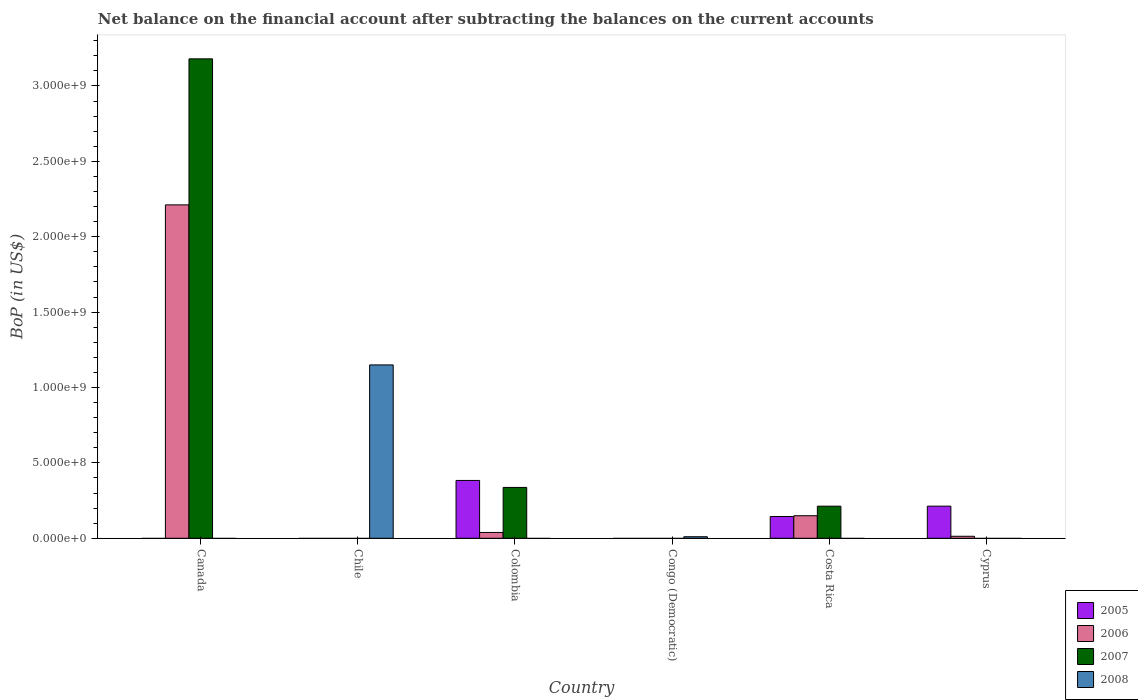Are the number of bars per tick equal to the number of legend labels?
Your answer should be very brief. No. Are the number of bars on each tick of the X-axis equal?
Provide a succinct answer. No. What is the Balance of Payments in 2006 in Cyprus?
Your response must be concise. 1.33e+07. Across all countries, what is the maximum Balance of Payments in 2005?
Keep it short and to the point. 3.84e+08. Across all countries, what is the minimum Balance of Payments in 2007?
Your answer should be compact. 0. What is the total Balance of Payments in 2006 in the graph?
Keep it short and to the point. 2.41e+09. What is the difference between the Balance of Payments in 2005 in Costa Rica and that in Cyprus?
Your response must be concise. -6.87e+07. What is the difference between the Balance of Payments in 2005 in Cyprus and the Balance of Payments in 2006 in Chile?
Your answer should be very brief. 2.13e+08. What is the average Balance of Payments in 2006 per country?
Your response must be concise. 4.02e+08. What is the difference between the Balance of Payments of/in 2007 and Balance of Payments of/in 2006 in Colombia?
Make the answer very short. 2.99e+08. What is the ratio of the Balance of Payments in 2007 in Canada to that in Costa Rica?
Your answer should be very brief. 14.93. Is the difference between the Balance of Payments in 2007 in Canada and Costa Rica greater than the difference between the Balance of Payments in 2006 in Canada and Costa Rica?
Your answer should be very brief. Yes. What is the difference between the highest and the second highest Balance of Payments in 2007?
Your answer should be compact. -1.24e+08. What is the difference between the highest and the lowest Balance of Payments in 2006?
Provide a succinct answer. 2.21e+09. How many bars are there?
Offer a terse response. 12. Are all the bars in the graph horizontal?
Your answer should be very brief. No. How many countries are there in the graph?
Ensure brevity in your answer.  6. Does the graph contain grids?
Offer a very short reply. No. How are the legend labels stacked?
Provide a succinct answer. Vertical. What is the title of the graph?
Give a very brief answer. Net balance on the financial account after subtracting the balances on the current accounts. What is the label or title of the X-axis?
Offer a terse response. Country. What is the label or title of the Y-axis?
Keep it short and to the point. BoP (in US$). What is the BoP (in US$) in 2005 in Canada?
Your answer should be very brief. 0. What is the BoP (in US$) in 2006 in Canada?
Provide a short and direct response. 2.21e+09. What is the BoP (in US$) in 2007 in Canada?
Offer a very short reply. 3.18e+09. What is the BoP (in US$) of 2005 in Chile?
Your answer should be compact. 0. What is the BoP (in US$) in 2006 in Chile?
Keep it short and to the point. 0. What is the BoP (in US$) of 2008 in Chile?
Make the answer very short. 1.15e+09. What is the BoP (in US$) of 2005 in Colombia?
Give a very brief answer. 3.84e+08. What is the BoP (in US$) in 2006 in Colombia?
Your response must be concise. 3.87e+07. What is the BoP (in US$) of 2007 in Colombia?
Your answer should be compact. 3.37e+08. What is the BoP (in US$) of 2008 in Colombia?
Make the answer very short. 0. What is the BoP (in US$) in 2005 in Congo (Democratic)?
Give a very brief answer. 0. What is the BoP (in US$) of 2006 in Congo (Democratic)?
Offer a terse response. 0. What is the BoP (in US$) of 2008 in Congo (Democratic)?
Offer a very short reply. 1.03e+07. What is the BoP (in US$) in 2005 in Costa Rica?
Offer a terse response. 1.44e+08. What is the BoP (in US$) of 2006 in Costa Rica?
Give a very brief answer. 1.50e+08. What is the BoP (in US$) of 2007 in Costa Rica?
Make the answer very short. 2.13e+08. What is the BoP (in US$) in 2005 in Cyprus?
Offer a very short reply. 2.13e+08. What is the BoP (in US$) in 2006 in Cyprus?
Keep it short and to the point. 1.33e+07. What is the BoP (in US$) of 2007 in Cyprus?
Your answer should be compact. 0. Across all countries, what is the maximum BoP (in US$) of 2005?
Your response must be concise. 3.84e+08. Across all countries, what is the maximum BoP (in US$) of 2006?
Ensure brevity in your answer.  2.21e+09. Across all countries, what is the maximum BoP (in US$) of 2007?
Provide a short and direct response. 3.18e+09. Across all countries, what is the maximum BoP (in US$) of 2008?
Provide a succinct answer. 1.15e+09. Across all countries, what is the minimum BoP (in US$) of 2006?
Offer a terse response. 0. Across all countries, what is the minimum BoP (in US$) of 2007?
Your response must be concise. 0. Across all countries, what is the minimum BoP (in US$) of 2008?
Provide a succinct answer. 0. What is the total BoP (in US$) of 2005 in the graph?
Your response must be concise. 7.41e+08. What is the total BoP (in US$) in 2006 in the graph?
Your answer should be very brief. 2.41e+09. What is the total BoP (in US$) of 2007 in the graph?
Your answer should be compact. 3.73e+09. What is the total BoP (in US$) of 2008 in the graph?
Give a very brief answer. 1.16e+09. What is the difference between the BoP (in US$) of 2006 in Canada and that in Colombia?
Your answer should be very brief. 2.17e+09. What is the difference between the BoP (in US$) of 2007 in Canada and that in Colombia?
Keep it short and to the point. 2.84e+09. What is the difference between the BoP (in US$) in 2006 in Canada and that in Costa Rica?
Offer a terse response. 2.06e+09. What is the difference between the BoP (in US$) in 2007 in Canada and that in Costa Rica?
Offer a very short reply. 2.97e+09. What is the difference between the BoP (in US$) of 2006 in Canada and that in Cyprus?
Make the answer very short. 2.20e+09. What is the difference between the BoP (in US$) of 2008 in Chile and that in Congo (Democratic)?
Your answer should be compact. 1.14e+09. What is the difference between the BoP (in US$) of 2005 in Colombia and that in Costa Rica?
Your answer should be very brief. 2.39e+08. What is the difference between the BoP (in US$) of 2006 in Colombia and that in Costa Rica?
Keep it short and to the point. -1.11e+08. What is the difference between the BoP (in US$) in 2007 in Colombia and that in Costa Rica?
Provide a short and direct response. 1.24e+08. What is the difference between the BoP (in US$) of 2005 in Colombia and that in Cyprus?
Provide a short and direct response. 1.70e+08. What is the difference between the BoP (in US$) in 2006 in Colombia and that in Cyprus?
Your answer should be very brief. 2.53e+07. What is the difference between the BoP (in US$) of 2005 in Costa Rica and that in Cyprus?
Give a very brief answer. -6.87e+07. What is the difference between the BoP (in US$) in 2006 in Costa Rica and that in Cyprus?
Your answer should be very brief. 1.36e+08. What is the difference between the BoP (in US$) of 2006 in Canada and the BoP (in US$) of 2008 in Chile?
Provide a succinct answer. 1.06e+09. What is the difference between the BoP (in US$) in 2007 in Canada and the BoP (in US$) in 2008 in Chile?
Make the answer very short. 2.03e+09. What is the difference between the BoP (in US$) in 2006 in Canada and the BoP (in US$) in 2007 in Colombia?
Provide a succinct answer. 1.87e+09. What is the difference between the BoP (in US$) of 2006 in Canada and the BoP (in US$) of 2008 in Congo (Democratic)?
Keep it short and to the point. 2.20e+09. What is the difference between the BoP (in US$) of 2007 in Canada and the BoP (in US$) of 2008 in Congo (Democratic)?
Keep it short and to the point. 3.17e+09. What is the difference between the BoP (in US$) of 2006 in Canada and the BoP (in US$) of 2007 in Costa Rica?
Offer a terse response. 2.00e+09. What is the difference between the BoP (in US$) of 2005 in Colombia and the BoP (in US$) of 2008 in Congo (Democratic)?
Provide a short and direct response. 3.73e+08. What is the difference between the BoP (in US$) of 2006 in Colombia and the BoP (in US$) of 2008 in Congo (Democratic)?
Provide a short and direct response. 2.84e+07. What is the difference between the BoP (in US$) in 2007 in Colombia and the BoP (in US$) in 2008 in Congo (Democratic)?
Make the answer very short. 3.27e+08. What is the difference between the BoP (in US$) in 2005 in Colombia and the BoP (in US$) in 2006 in Costa Rica?
Your answer should be compact. 2.34e+08. What is the difference between the BoP (in US$) in 2005 in Colombia and the BoP (in US$) in 2007 in Costa Rica?
Your answer should be compact. 1.71e+08. What is the difference between the BoP (in US$) in 2006 in Colombia and the BoP (in US$) in 2007 in Costa Rica?
Give a very brief answer. -1.74e+08. What is the difference between the BoP (in US$) of 2005 in Colombia and the BoP (in US$) of 2006 in Cyprus?
Offer a very short reply. 3.70e+08. What is the difference between the BoP (in US$) of 2005 in Costa Rica and the BoP (in US$) of 2006 in Cyprus?
Offer a very short reply. 1.31e+08. What is the average BoP (in US$) in 2005 per country?
Offer a very short reply. 1.24e+08. What is the average BoP (in US$) of 2006 per country?
Offer a terse response. 4.02e+08. What is the average BoP (in US$) of 2007 per country?
Offer a terse response. 6.22e+08. What is the average BoP (in US$) of 2008 per country?
Ensure brevity in your answer.  1.93e+08. What is the difference between the BoP (in US$) of 2006 and BoP (in US$) of 2007 in Canada?
Ensure brevity in your answer.  -9.69e+08. What is the difference between the BoP (in US$) in 2005 and BoP (in US$) in 2006 in Colombia?
Your response must be concise. 3.45e+08. What is the difference between the BoP (in US$) of 2005 and BoP (in US$) of 2007 in Colombia?
Ensure brevity in your answer.  4.63e+07. What is the difference between the BoP (in US$) of 2006 and BoP (in US$) of 2007 in Colombia?
Give a very brief answer. -2.99e+08. What is the difference between the BoP (in US$) of 2005 and BoP (in US$) of 2006 in Costa Rica?
Offer a very short reply. -5.05e+06. What is the difference between the BoP (in US$) of 2005 and BoP (in US$) of 2007 in Costa Rica?
Your response must be concise. -6.85e+07. What is the difference between the BoP (in US$) of 2006 and BoP (in US$) of 2007 in Costa Rica?
Keep it short and to the point. -6.34e+07. What is the difference between the BoP (in US$) of 2005 and BoP (in US$) of 2006 in Cyprus?
Ensure brevity in your answer.  2.00e+08. What is the ratio of the BoP (in US$) of 2006 in Canada to that in Colombia?
Ensure brevity in your answer.  57.22. What is the ratio of the BoP (in US$) of 2007 in Canada to that in Colombia?
Offer a terse response. 9.43. What is the ratio of the BoP (in US$) of 2006 in Canada to that in Costa Rica?
Make the answer very short. 14.79. What is the ratio of the BoP (in US$) in 2007 in Canada to that in Costa Rica?
Keep it short and to the point. 14.93. What is the ratio of the BoP (in US$) in 2006 in Canada to that in Cyprus?
Offer a very short reply. 165.78. What is the ratio of the BoP (in US$) in 2008 in Chile to that in Congo (Democratic)?
Your response must be concise. 111.64. What is the ratio of the BoP (in US$) of 2005 in Colombia to that in Costa Rica?
Make the answer very short. 2.66. What is the ratio of the BoP (in US$) of 2006 in Colombia to that in Costa Rica?
Offer a very short reply. 0.26. What is the ratio of the BoP (in US$) in 2007 in Colombia to that in Costa Rica?
Your response must be concise. 1.58. What is the ratio of the BoP (in US$) of 2005 in Colombia to that in Cyprus?
Offer a terse response. 1.8. What is the ratio of the BoP (in US$) of 2006 in Colombia to that in Cyprus?
Give a very brief answer. 2.9. What is the ratio of the BoP (in US$) of 2005 in Costa Rica to that in Cyprus?
Keep it short and to the point. 0.68. What is the ratio of the BoP (in US$) of 2006 in Costa Rica to that in Cyprus?
Keep it short and to the point. 11.21. What is the difference between the highest and the second highest BoP (in US$) of 2005?
Offer a terse response. 1.70e+08. What is the difference between the highest and the second highest BoP (in US$) in 2006?
Make the answer very short. 2.06e+09. What is the difference between the highest and the second highest BoP (in US$) of 2007?
Your answer should be very brief. 2.84e+09. What is the difference between the highest and the lowest BoP (in US$) in 2005?
Your response must be concise. 3.84e+08. What is the difference between the highest and the lowest BoP (in US$) of 2006?
Give a very brief answer. 2.21e+09. What is the difference between the highest and the lowest BoP (in US$) of 2007?
Make the answer very short. 3.18e+09. What is the difference between the highest and the lowest BoP (in US$) of 2008?
Ensure brevity in your answer.  1.15e+09. 